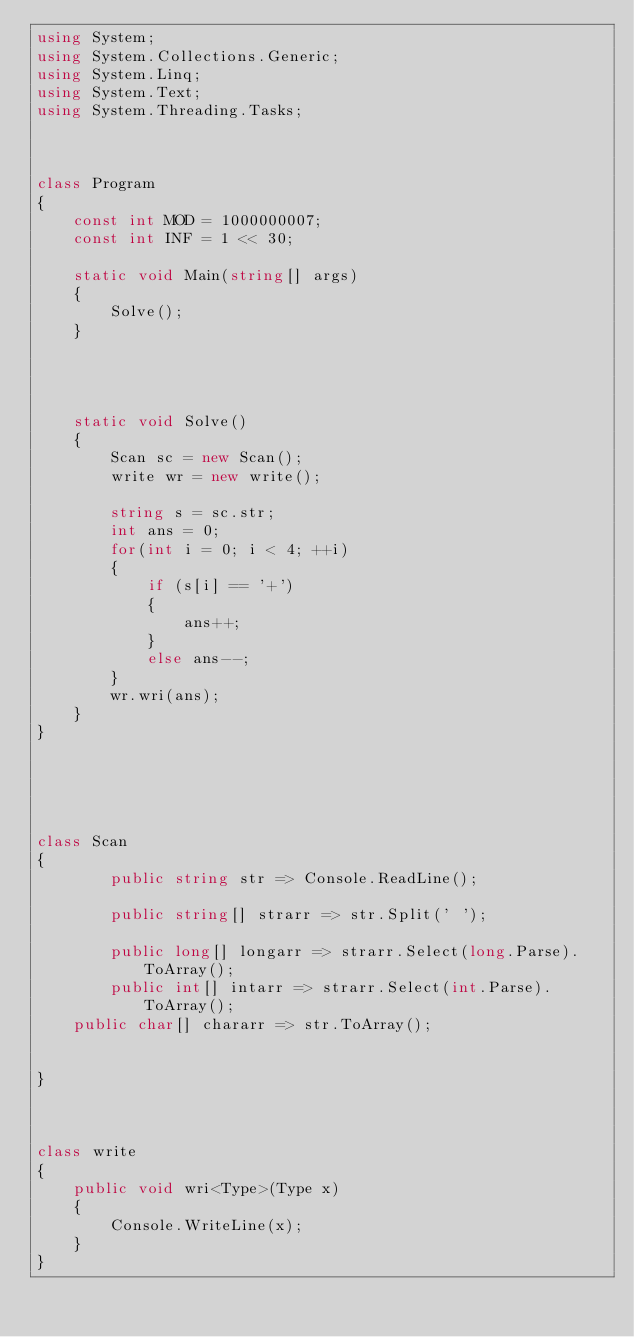<code> <loc_0><loc_0><loc_500><loc_500><_C#_>using System;
using System.Collections.Generic;
using System.Linq;
using System.Text;
using System.Threading.Tasks;



class Program
{
    const int MOD = 1000000007;
    const int INF = 1 << 30;

    static void Main(string[] args)
    {
        Solve();
    }




    static void Solve()
    {
        Scan sc = new Scan();
        write wr = new write();

        string s = sc.str;
        int ans = 0;
        for(int i = 0; i < 4; ++i)
        {
            if (s[i] == '+')
            {
                ans++;
            }
            else ans--;
        }
        wr.wri(ans);
    }
}
    




class Scan
{
        public string str => Console.ReadLine();

        public string[] strarr => str.Split(' ');

        public long[] longarr => strarr.Select(long.Parse).ToArray();
        public int[] intarr => strarr.Select(int.Parse).ToArray();
    public char[] chararr => str.ToArray();


}



class write
{
    public void wri<Type>(Type x)
    {
        Console.WriteLine(x);
    }
}
</code> 